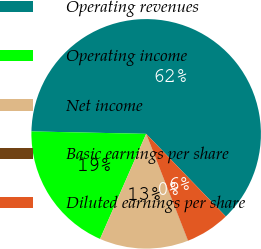<chart> <loc_0><loc_0><loc_500><loc_500><pie_chart><fcel>Operating revenues<fcel>Operating income<fcel>Net income<fcel>Basic earnings per share<fcel>Diluted earnings per share<nl><fcel>62.45%<fcel>18.75%<fcel>12.51%<fcel>0.02%<fcel>6.26%<nl></chart> 